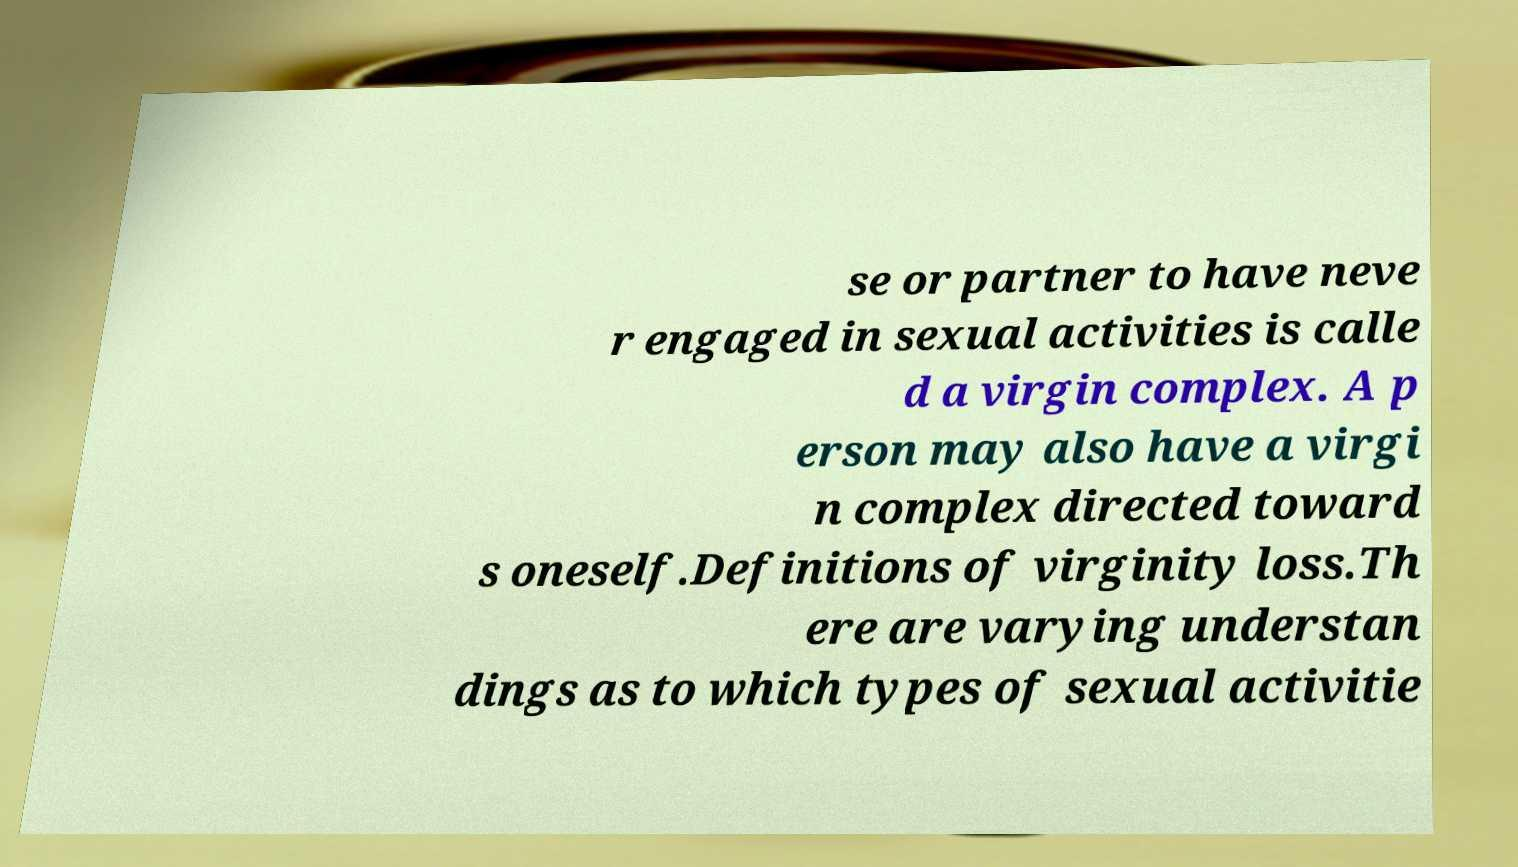Can you accurately transcribe the text from the provided image for me? se or partner to have neve r engaged in sexual activities is calle d a virgin complex. A p erson may also have a virgi n complex directed toward s oneself.Definitions of virginity loss.Th ere are varying understan dings as to which types of sexual activitie 